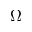Convert formula to latex. <formula><loc_0><loc_0><loc_500><loc_500>\Omega _ { - }</formula> 